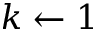Convert formula to latex. <formula><loc_0><loc_0><loc_500><loc_500>k \gets 1</formula> 